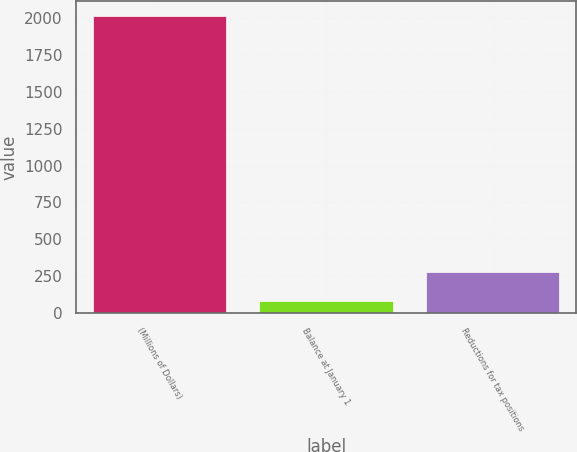Convert chart to OTSL. <chart><loc_0><loc_0><loc_500><loc_500><bar_chart><fcel>(Millions of Dollars)<fcel>Balance at January 1<fcel>Reductions for tax positions<nl><fcel>2013<fcel>86<fcel>278.7<nl></chart> 